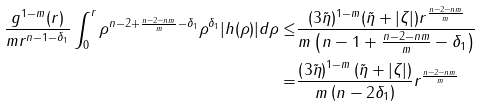<formula> <loc_0><loc_0><loc_500><loc_500>\frac { g ^ { 1 - m } ( r ) } { m r ^ { n - 1 - \delta _ { 1 } } } \int _ { 0 } ^ { r } \rho ^ { n - 2 + \frac { n - 2 - n m } { m } - \delta _ { 1 } } \rho ^ { \delta _ { 1 } } | h ( \rho ) | d \rho \leq & \frac { ( 3 \tilde { \eta } ) ^ { 1 - m } ( \tilde { \eta } + | \zeta | ) r ^ { \frac { n - 2 - n m } { m } } } { m \left ( n - 1 + \frac { n - 2 - n m } { m } - \delta _ { 1 } \right ) } \\ = & \frac { \left ( { 3 \tilde { \eta } } \right ) ^ { 1 - m } \left ( \tilde { \eta } + | \zeta | \right ) } { m \left ( n - 2 \delta _ { 1 } \right ) } { r ^ { \frac { n - 2 - n m } { m } } }</formula> 